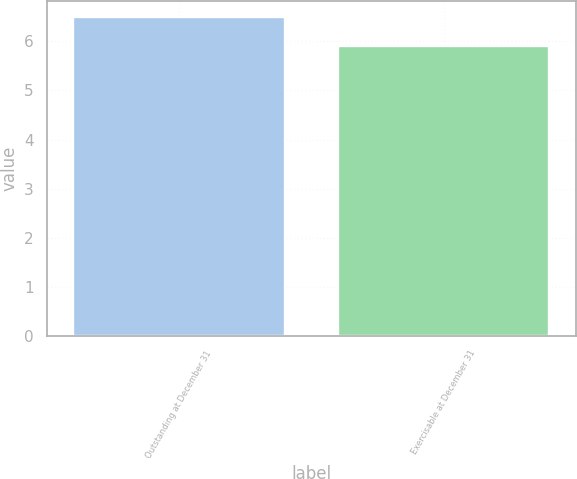<chart> <loc_0><loc_0><loc_500><loc_500><bar_chart><fcel>Outstanding at December 31<fcel>Exercisable at December 31<nl><fcel>6.5<fcel>5.9<nl></chart> 